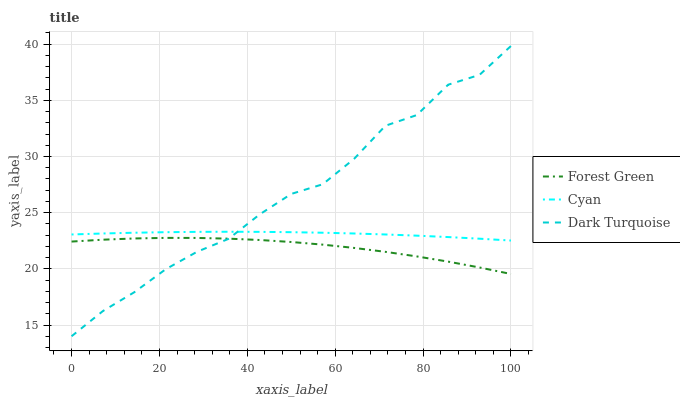Does Forest Green have the minimum area under the curve?
Answer yes or no. Yes. Does Dark Turquoise have the maximum area under the curve?
Answer yes or no. Yes. Does Dark Turquoise have the minimum area under the curve?
Answer yes or no. No. Does Forest Green have the maximum area under the curve?
Answer yes or no. No. Is Cyan the smoothest?
Answer yes or no. Yes. Is Dark Turquoise the roughest?
Answer yes or no. Yes. Is Forest Green the smoothest?
Answer yes or no. No. Is Forest Green the roughest?
Answer yes or no. No. Does Dark Turquoise have the lowest value?
Answer yes or no. Yes. Does Forest Green have the lowest value?
Answer yes or no. No. Does Dark Turquoise have the highest value?
Answer yes or no. Yes. Does Forest Green have the highest value?
Answer yes or no. No. Is Forest Green less than Cyan?
Answer yes or no. Yes. Is Cyan greater than Forest Green?
Answer yes or no. Yes. Does Forest Green intersect Dark Turquoise?
Answer yes or no. Yes. Is Forest Green less than Dark Turquoise?
Answer yes or no. No. Is Forest Green greater than Dark Turquoise?
Answer yes or no. No. Does Forest Green intersect Cyan?
Answer yes or no. No. 